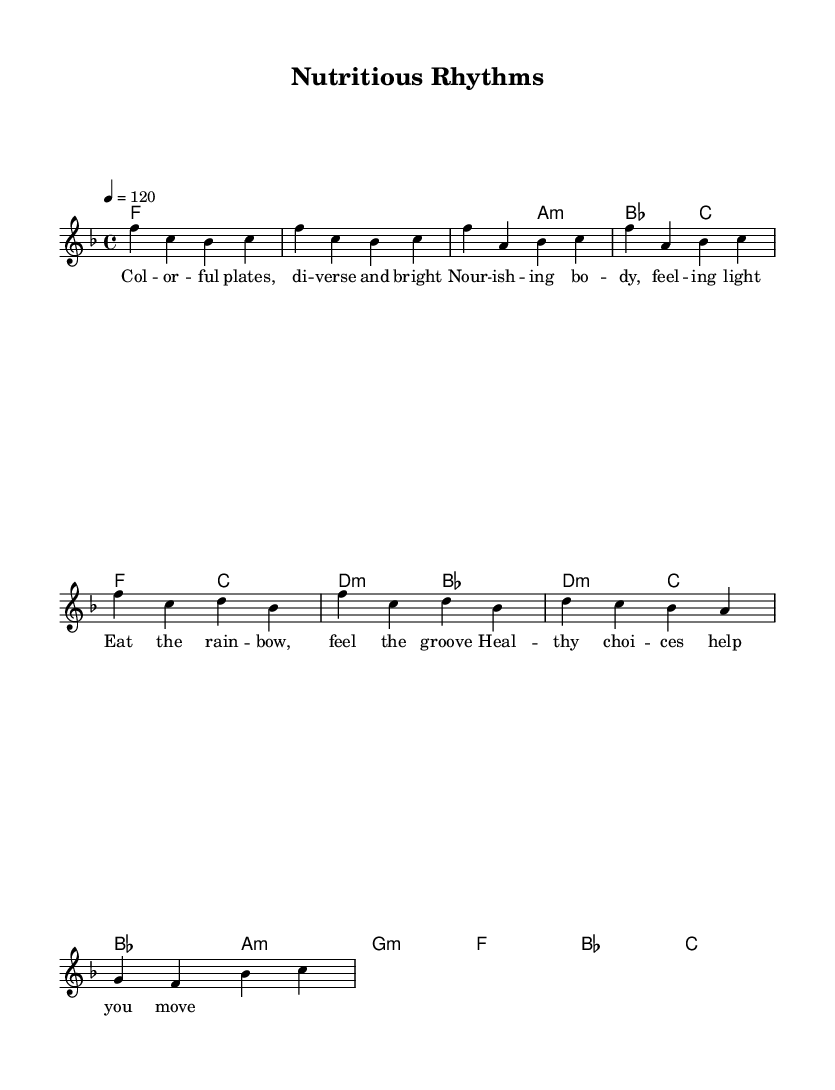What is the key signature of this music? The key signature shown in the music is F major, which has one flat (B flat). This can be identified by looking for the flat sign at the beginning of the staff.
Answer: F major What is the time signature of this music? The time signature is 4/4, indicated at the start of the score. This means there are four beats in each measure, and the quarter note receives one beat.
Answer: 4/4 What is the tempo marking for the piece? The tempo marking is indicated as 4 = 120, meaning there are 120 beats per minute. This suggests a brisk pace for the music.
Answer: 120 How many measures are in the verse? The verse consists of two measures, which can be counted from the music notation where the verse is highlighted.
Answer: 2 What type of chords are used in the chorus? The chorus predominantly uses major and minor chords, which can be identified in the chord progression shown under the chorus section.
Answer: Major and minor What is the primary theme conveyed through the lyrics? The lyrics celebrate dietary diversity and healthy eating, emphasizing the importance of colorful, nutritious food choices and their positive effects on well-being.
Answer: Dietary diversity What musical form is represented in this piece? The piece follows a simple structure with verses and a chorus, a common format in rhythm and blues music, allowing for repetition and lyrical emphasis.
Answer: Verse-Chorus 